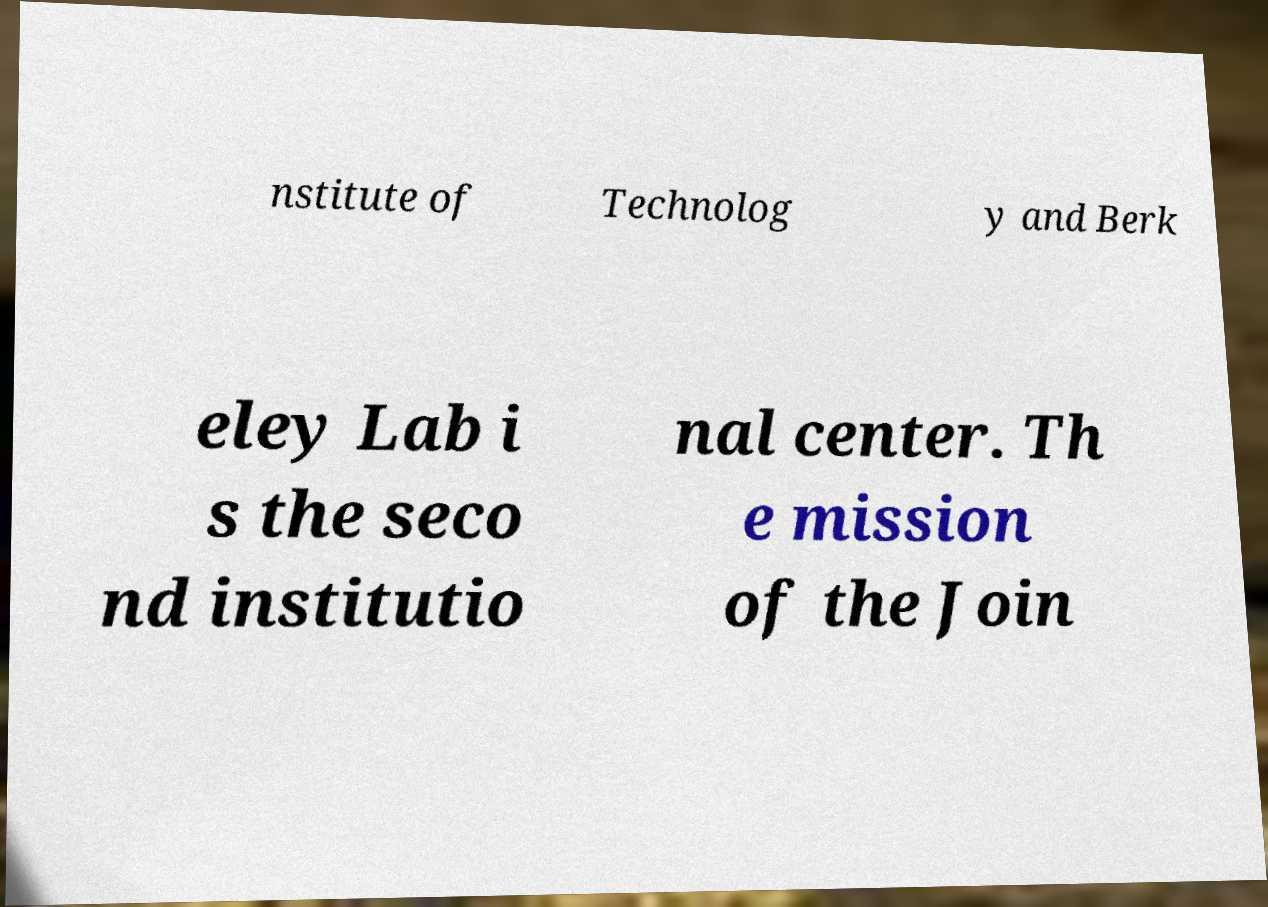I need the written content from this picture converted into text. Can you do that? nstitute of Technolog y and Berk eley Lab i s the seco nd institutio nal center. Th e mission of the Join 